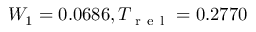<formula> <loc_0><loc_0><loc_500><loc_500>W _ { 1 } = 0 . 0 6 8 6 , T _ { r e l } = 0 . 2 7 7 0</formula> 